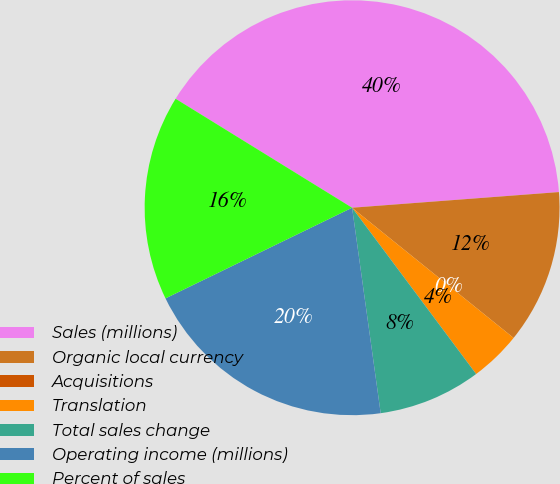Convert chart. <chart><loc_0><loc_0><loc_500><loc_500><pie_chart><fcel>Sales (millions)<fcel>Organic local currency<fcel>Acquisitions<fcel>Translation<fcel>Total sales change<fcel>Operating income (millions)<fcel>Percent of sales<nl><fcel>39.99%<fcel>12.0%<fcel>0.0%<fcel>4.0%<fcel>8.0%<fcel>20.0%<fcel>16.0%<nl></chart> 